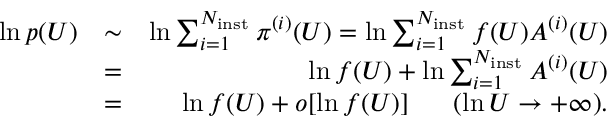Convert formula to latex. <formula><loc_0><loc_0><loc_500><loc_500>\begin{array} { r l r } { \ln p ( U ) } & { \sim } & { \ln \sum _ { i = 1 } ^ { N _ { i n s t } } \pi ^ { ( i ) } ( U ) = \ln \sum _ { i = 1 } ^ { N _ { i n s t } } f ( U ) A ^ { ( i ) } ( U ) } \\ & { = } & { \ln f ( U ) + \ln \sum _ { i = 1 } ^ { N _ { i n s t } } A ^ { ( i ) } ( U ) } \\ & { = } & { \ln f ( U ) + o [ \ln f ( U ) ] \quad \ ( \ln U \to + \infty ) . } \end{array}</formula> 